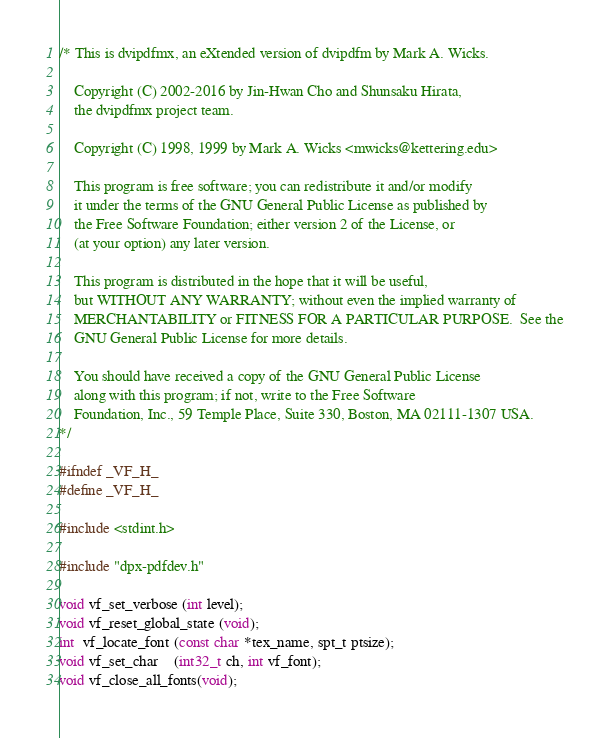<code> <loc_0><loc_0><loc_500><loc_500><_C_>/* This is dvipdfmx, an eXtended version of dvipdfm by Mark A. Wicks.

    Copyright (C) 2002-2016 by Jin-Hwan Cho and Shunsaku Hirata,
    the dvipdfmx project team.

    Copyright (C) 1998, 1999 by Mark A. Wicks <mwicks@kettering.edu>

    This program is free software; you can redistribute it and/or modify
    it under the terms of the GNU General Public License as published by
    the Free Software Foundation; either version 2 of the License, or
    (at your option) any later version.

    This program is distributed in the hope that it will be useful,
    but WITHOUT ANY WARRANTY; without even the implied warranty of
    MERCHANTABILITY or FITNESS FOR A PARTICULAR PURPOSE.  See the
    GNU General Public License for more details.

    You should have received a copy of the GNU General Public License
    along with this program; if not, write to the Free Software
    Foundation, Inc., 59 Temple Place, Suite 330, Boston, MA 02111-1307 USA.
*/

#ifndef _VF_H_
#define _VF_H_

#include <stdint.h>

#include "dpx-pdfdev.h"

void vf_set_verbose (int level);
void vf_reset_global_state (void);
int  vf_locate_font (const char *tex_name, spt_t ptsize);
void vf_set_char    (int32_t ch, int vf_font);
void vf_close_all_fonts(void);
</code> 